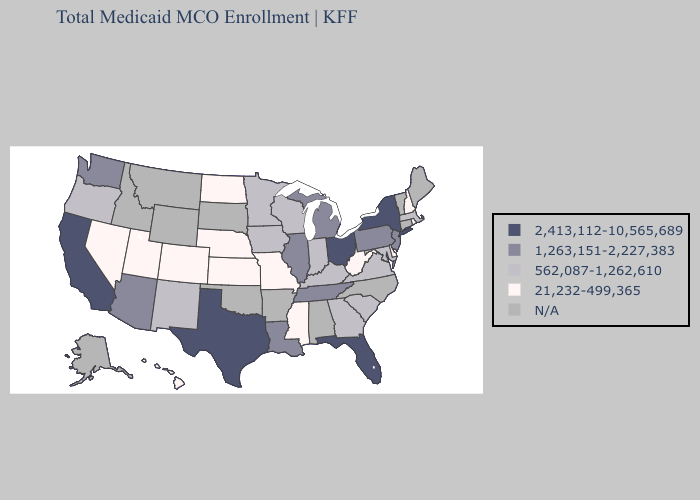Does Mississippi have the lowest value in the USA?
Quick response, please. Yes. Does West Virginia have the lowest value in the South?
Concise answer only. Yes. What is the highest value in the USA?
Concise answer only. 2,413,112-10,565,689. How many symbols are there in the legend?
Write a very short answer. 5. What is the value of Idaho?
Be succinct. N/A. What is the value of Oklahoma?
Be succinct. N/A. Name the states that have a value in the range 21,232-499,365?
Quick response, please. Colorado, Delaware, Hawaii, Kansas, Mississippi, Missouri, Nebraska, Nevada, New Hampshire, North Dakota, Rhode Island, Utah, West Virginia. Does West Virginia have the lowest value in the USA?
Quick response, please. Yes. What is the value of Arkansas?
Concise answer only. N/A. Name the states that have a value in the range 562,087-1,262,610?
Quick response, please. Georgia, Indiana, Iowa, Kentucky, Maryland, Massachusetts, Minnesota, New Mexico, Oregon, South Carolina, Virginia, Wisconsin. Does West Virginia have the lowest value in the South?
Short answer required. Yes. Is the legend a continuous bar?
Answer briefly. No. What is the value of Wyoming?
Give a very brief answer. N/A. 